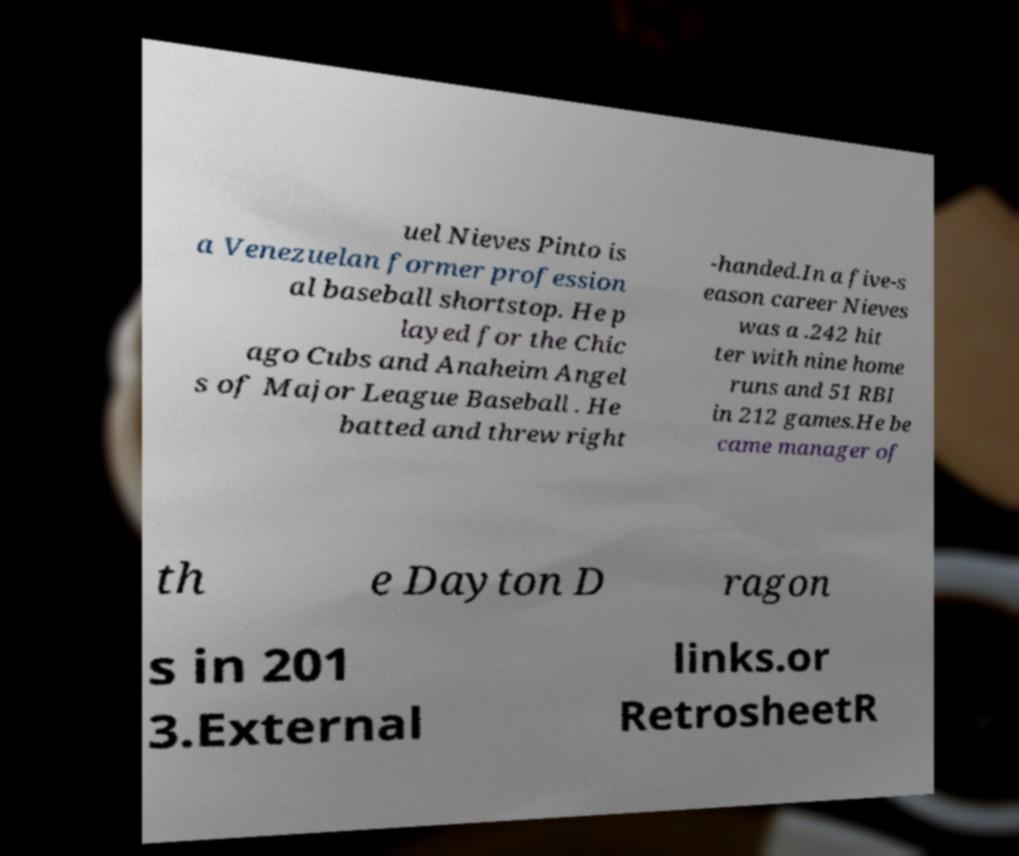Please read and relay the text visible in this image. What does it say? uel Nieves Pinto is a Venezuelan former profession al baseball shortstop. He p layed for the Chic ago Cubs and Anaheim Angel s of Major League Baseball . He batted and threw right -handed.In a five-s eason career Nieves was a .242 hit ter with nine home runs and 51 RBI in 212 games.He be came manager of th e Dayton D ragon s in 201 3.External links.or RetrosheetR 